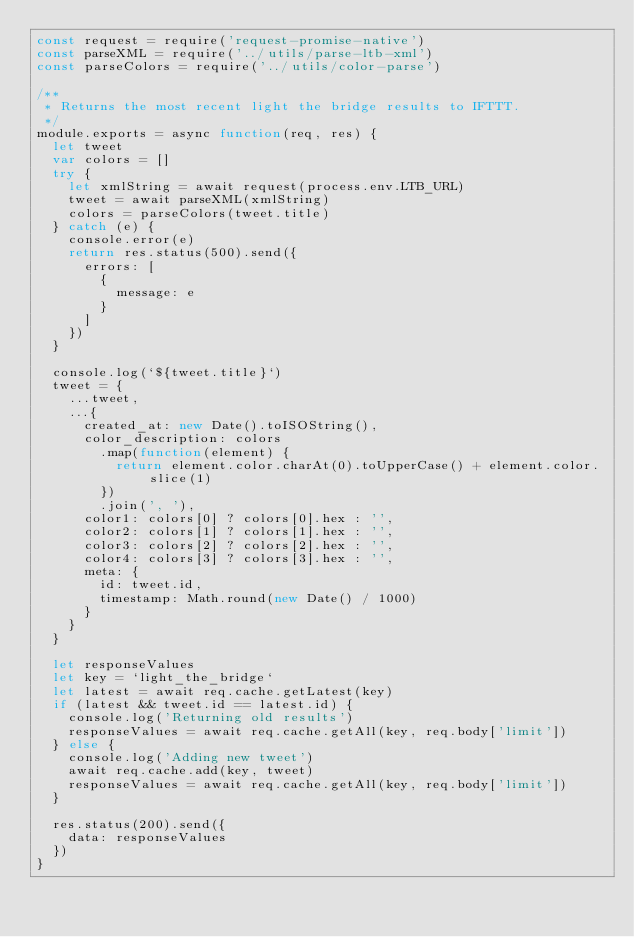Convert code to text. <code><loc_0><loc_0><loc_500><loc_500><_JavaScript_>const request = require('request-promise-native')
const parseXML = require('../utils/parse-ltb-xml')
const parseColors = require('../utils/color-parse')

/**
 * Returns the most recent light the bridge results to IFTTT.
 */
module.exports = async function(req, res) {
  let tweet
  var colors = []
  try {
    let xmlString = await request(process.env.LTB_URL)
    tweet = await parseXML(xmlString)
    colors = parseColors(tweet.title)
  } catch (e) {
    console.error(e)
    return res.status(500).send({
      errors: [
        {
          message: e
        }
      ]
    })
  }

  console.log(`${tweet.title}`)
  tweet = {
    ...tweet,
    ...{
      created_at: new Date().toISOString(),
      color_description: colors
        .map(function(element) {
          return element.color.charAt(0).toUpperCase() + element.color.slice(1)
        })
        .join(', '),
      color1: colors[0] ? colors[0].hex : '',
      color2: colors[1] ? colors[1].hex : '',
      color3: colors[2] ? colors[2].hex : '',
      color4: colors[3] ? colors[3].hex : '',
      meta: {
        id: tweet.id,
        timestamp: Math.round(new Date() / 1000)
      }
    }
  }

  let responseValues
  let key = `light_the_bridge`
  let latest = await req.cache.getLatest(key)
  if (latest && tweet.id == latest.id) {
    console.log('Returning old results')
    responseValues = await req.cache.getAll(key, req.body['limit'])
  } else {
    console.log('Adding new tweet')
    await req.cache.add(key, tweet)
    responseValues = await req.cache.getAll(key, req.body['limit'])
  }

  res.status(200).send({
    data: responseValues
  })
}
</code> 